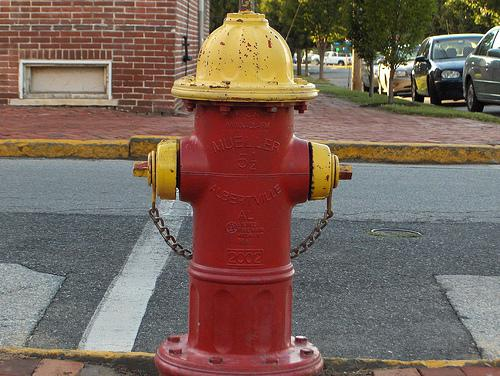Question: where is the fire hydrant located?
Choices:
A. On the grass.
B. Near the driveway.
C. On the sidewalk.
D. Next to the fence.
Answer with the letter. Answer: C Question: what main color of the fire hydrant?
Choices:
A. Yellow.
B. Red.
C. Blue.
D. White.
Answer with the letter. Answer: B Question: what are the vehicles called?
Choices:
A. Trucks.
B. SUV's.
C. Campers.
D. Cars.
Answer with the letter. Answer: D 